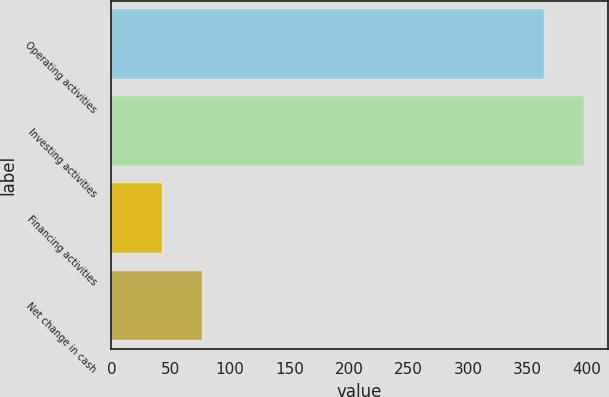<chart> <loc_0><loc_0><loc_500><loc_500><bar_chart><fcel>Operating activities<fcel>Investing activities<fcel>Financing activities<fcel>Net change in cash<nl><fcel>364<fcel>397.6<fcel>43<fcel>76.6<nl></chart> 